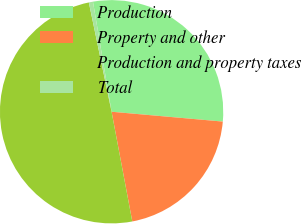Convert chart. <chart><loc_0><loc_0><loc_500><loc_500><pie_chart><fcel>Production<fcel>Property and other<fcel>Production and property taxes<fcel>Total<nl><fcel>29.07%<fcel>20.63%<fcel>49.7%<fcel>0.6%<nl></chart> 